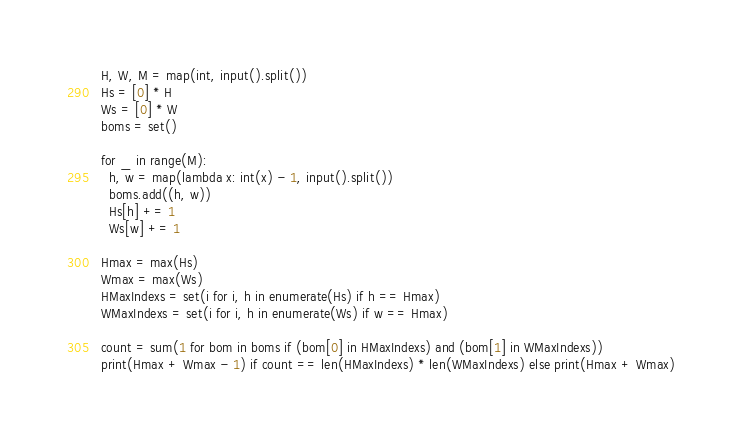<code> <loc_0><loc_0><loc_500><loc_500><_Python_>H, W, M = map(int, input().split())
Hs = [0] * H
Ws = [0] * W
boms = set()

for _ in range(M):
  h, w = map(lambda x: int(x) - 1, input().split())
  boms.add((h, w))
  Hs[h] += 1
  Ws[w] += 1
  
Hmax = max(Hs)
Wmax = max(Ws)
HMaxIndexs = set(i for i, h in enumerate(Hs) if h == Hmax)
WMaxIndexs = set(i for i, h in enumerate(Ws) if w == Hmax)

count = sum(1 for bom in boms if (bom[0] in HMaxIndexs) and (bom[1] in WMaxIndexs))
print(Hmax + Wmax - 1) if count == len(HMaxIndexs) * len(WMaxIndexs) else print(Hmax + Wmax)

</code> 